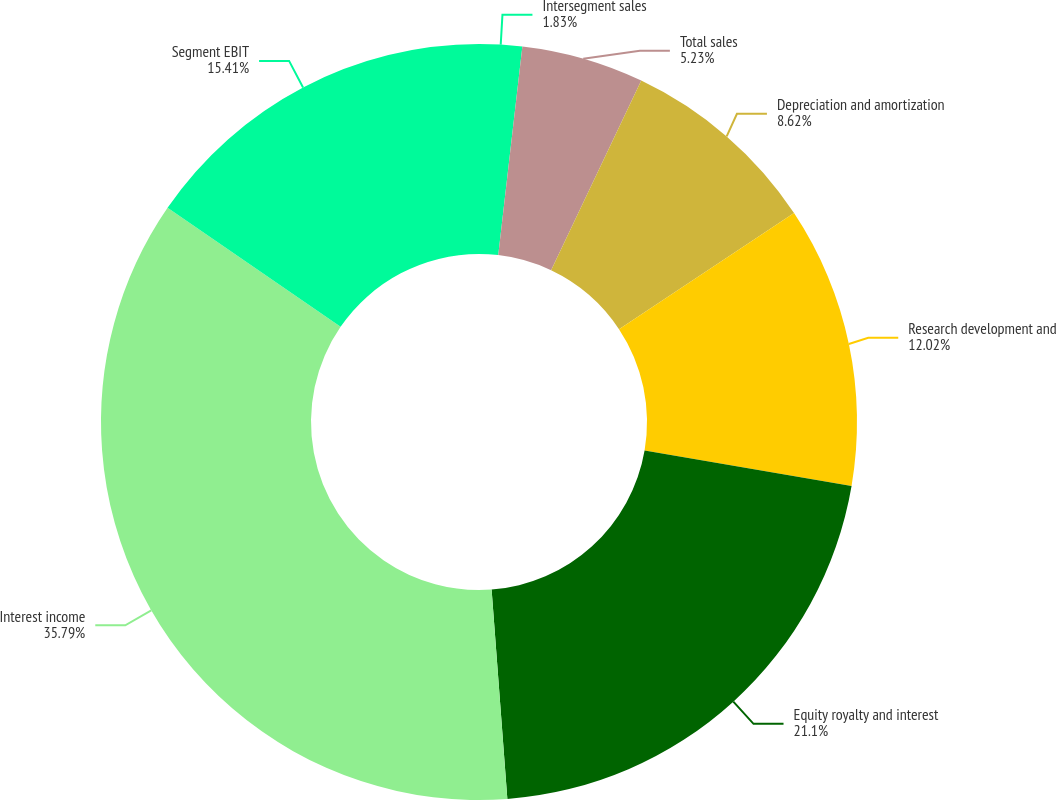Convert chart. <chart><loc_0><loc_0><loc_500><loc_500><pie_chart><fcel>Intersegment sales<fcel>Total sales<fcel>Depreciation and amortization<fcel>Research development and<fcel>Equity royalty and interest<fcel>Interest income<fcel>Segment EBIT<nl><fcel>1.83%<fcel>5.23%<fcel>8.62%<fcel>12.02%<fcel>21.1%<fcel>35.78%<fcel>15.41%<nl></chart> 